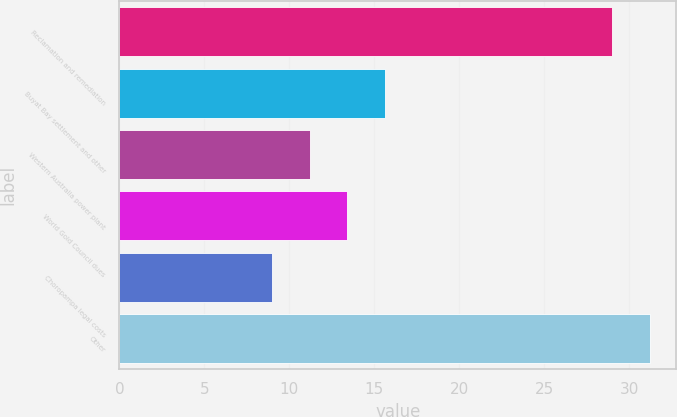Convert chart to OTSL. <chart><loc_0><loc_0><loc_500><loc_500><bar_chart><fcel>Reclamation and remediation<fcel>Buyat Bay settlement and other<fcel>Western Australia power plant<fcel>World Gold Council dues<fcel>Choropampa legal costs<fcel>Other<nl><fcel>29<fcel>15.6<fcel>11.2<fcel>13.4<fcel>9<fcel>31.2<nl></chart> 